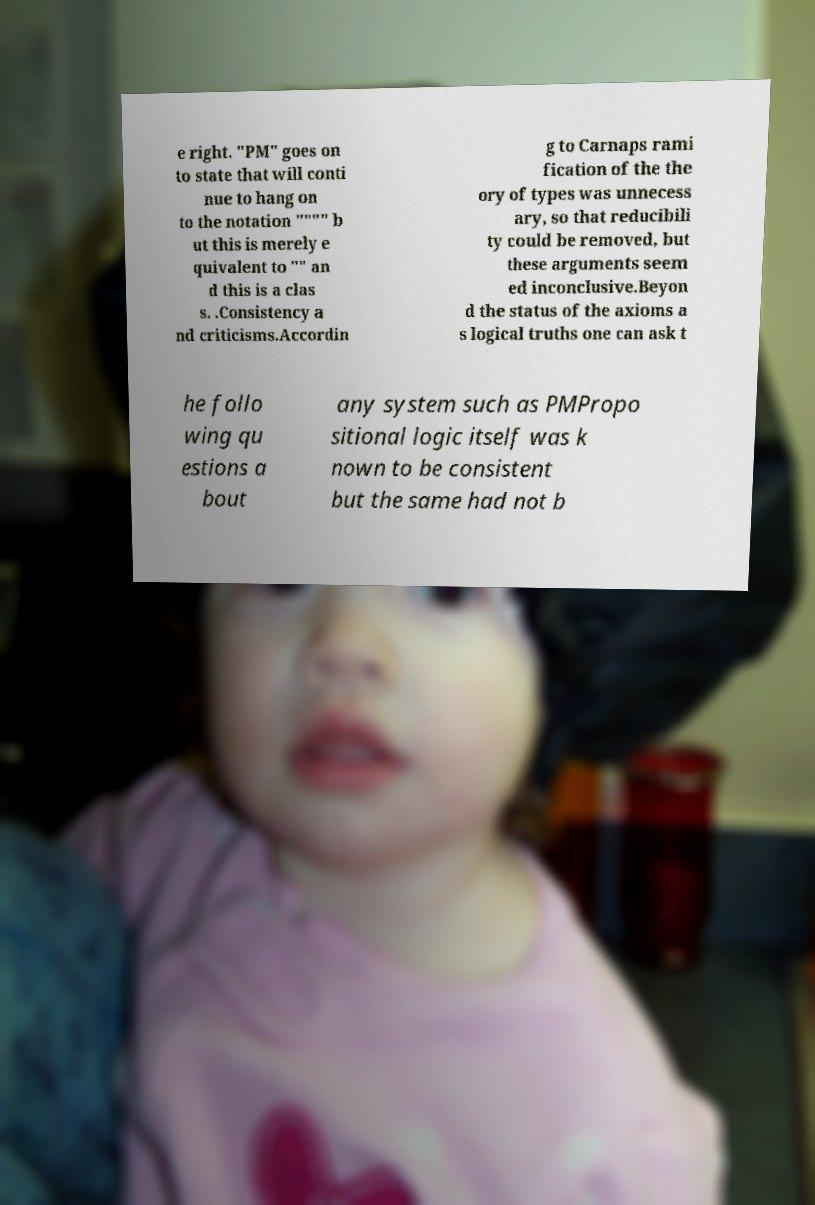What messages or text are displayed in this image? I need them in a readable, typed format. e right. "PM" goes on to state that will conti nue to hang on to the notation """" b ut this is merely e quivalent to "" an d this is a clas s. .Consistency a nd criticisms.Accordin g to Carnaps rami fication of the the ory of types was unnecess ary, so that reducibili ty could be removed, but these arguments seem ed inconclusive.Beyon d the status of the axioms a s logical truths one can ask t he follo wing qu estions a bout any system such as PMPropo sitional logic itself was k nown to be consistent but the same had not b 